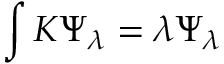<formula> <loc_0><loc_0><loc_500><loc_500>\int K \Psi _ { \lambda } = \lambda \Psi _ { \lambda }</formula> 